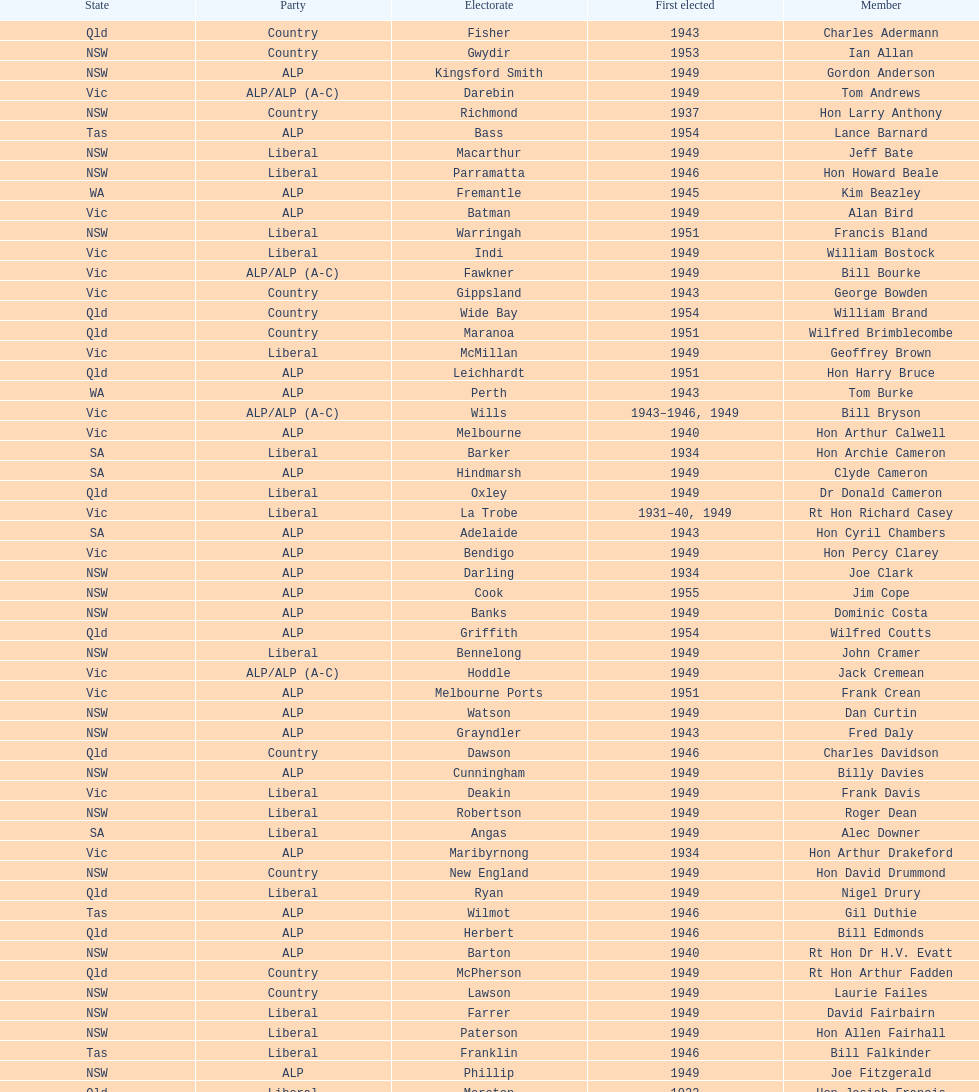After tom burke was elected, what was the next year where another tom would be elected? 1937. 